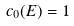Convert formula to latex. <formula><loc_0><loc_0><loc_500><loc_500>c _ { 0 } ( E ) = 1</formula> 